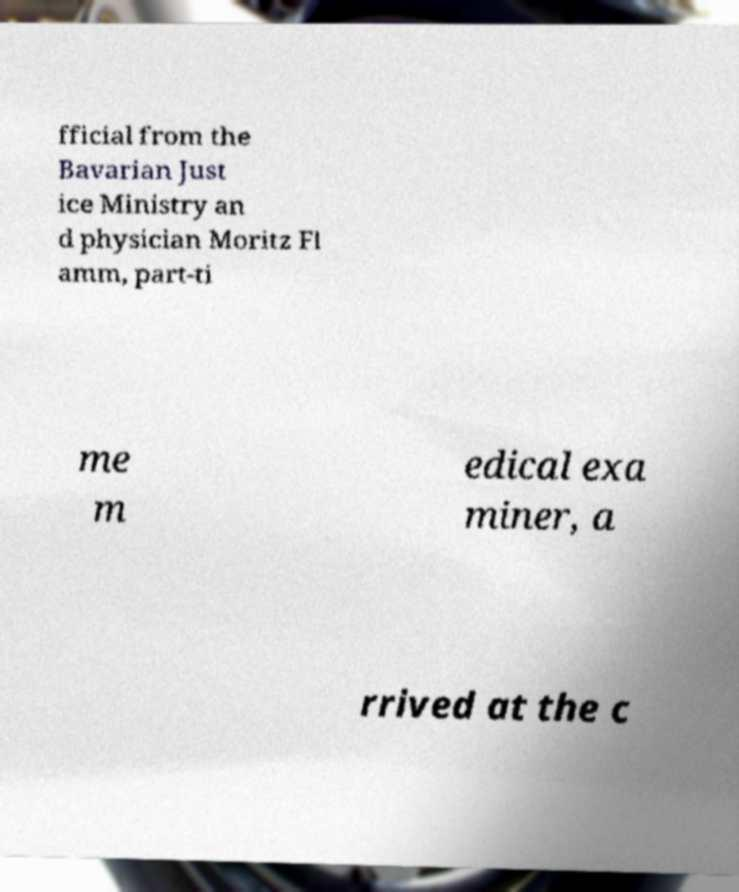Can you read and provide the text displayed in the image?This photo seems to have some interesting text. Can you extract and type it out for me? fficial from the Bavarian Just ice Ministry an d physician Moritz Fl amm, part-ti me m edical exa miner, a rrived at the c 